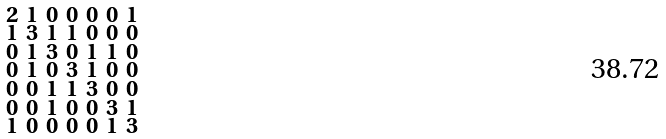<formula> <loc_0><loc_0><loc_500><loc_500>\begin{smallmatrix} 2 & 1 & 0 & 0 & 0 & 0 & 1 \\ 1 & 3 & 1 & 1 & 0 & 0 & 0 \\ 0 & 1 & 3 & 0 & 1 & 1 & 0 \\ 0 & 1 & 0 & 3 & 1 & 0 & 0 \\ 0 & 0 & 1 & 1 & 3 & 0 & 0 \\ 0 & 0 & 1 & 0 & 0 & 3 & 1 \\ 1 & 0 & 0 & 0 & 0 & 1 & 3 \end{smallmatrix}</formula> 